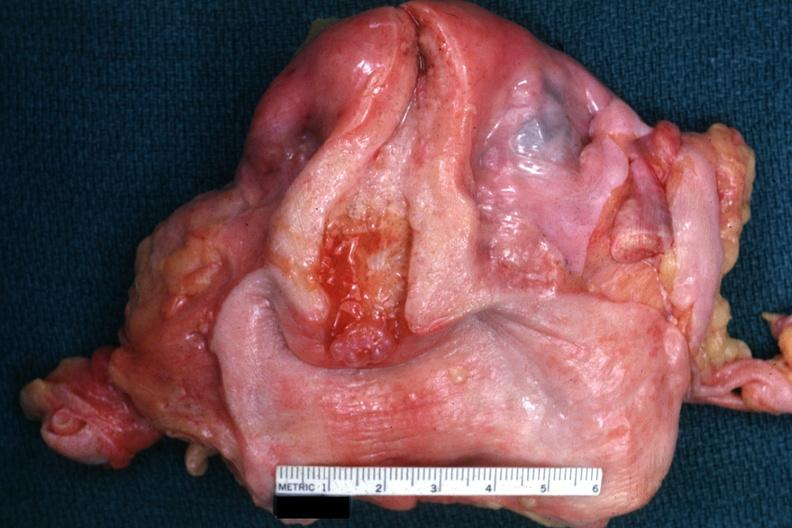s endocervical polyp present?
Answer the question using a single word or phrase. Yes 